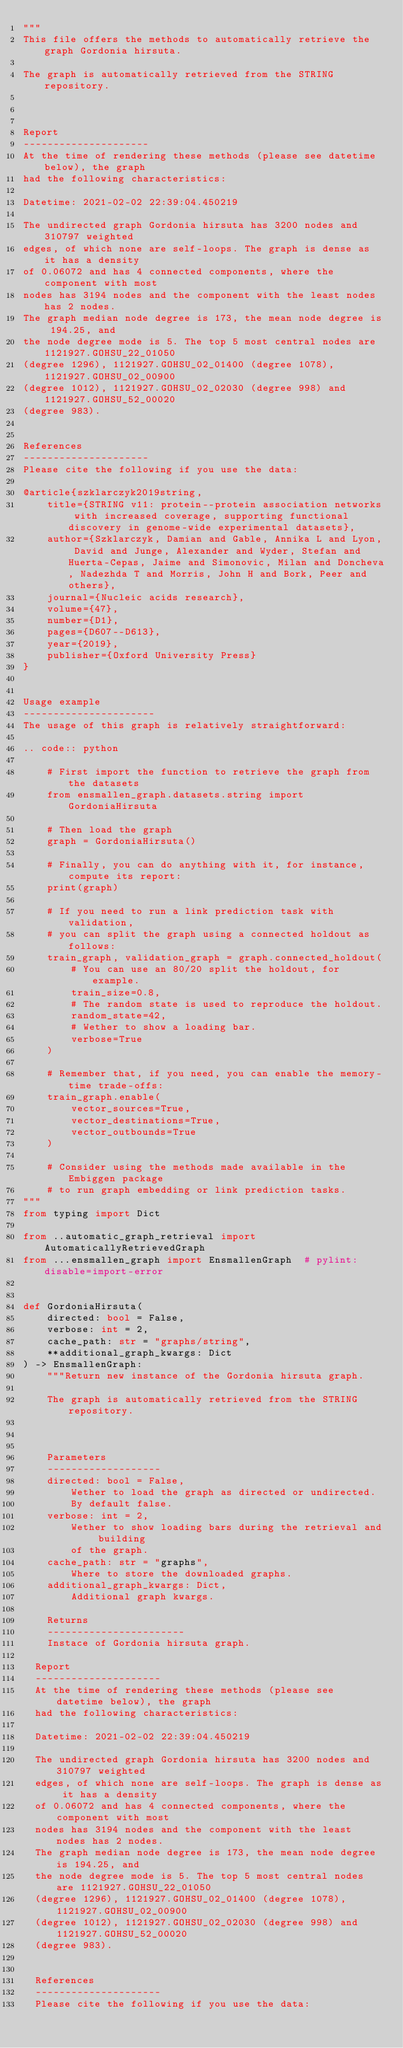<code> <loc_0><loc_0><loc_500><loc_500><_Python_>"""
This file offers the methods to automatically retrieve the graph Gordonia hirsuta.

The graph is automatically retrieved from the STRING repository. 



Report
---------------------
At the time of rendering these methods (please see datetime below), the graph
had the following characteristics:

Datetime: 2021-02-02 22:39:04.450219

The undirected graph Gordonia hirsuta has 3200 nodes and 310797 weighted
edges, of which none are self-loops. The graph is dense as it has a density
of 0.06072 and has 4 connected components, where the component with most
nodes has 3194 nodes and the component with the least nodes has 2 nodes.
The graph median node degree is 173, the mean node degree is 194.25, and
the node degree mode is 5. The top 5 most central nodes are 1121927.GOHSU_22_01050
(degree 1296), 1121927.GOHSU_02_01400 (degree 1078), 1121927.GOHSU_02_00900
(degree 1012), 1121927.GOHSU_02_02030 (degree 998) and 1121927.GOHSU_52_00020
(degree 983).


References
---------------------
Please cite the following if you use the data:

@article{szklarczyk2019string,
    title={STRING v11: protein--protein association networks with increased coverage, supporting functional discovery in genome-wide experimental datasets},
    author={Szklarczyk, Damian and Gable, Annika L and Lyon, David and Junge, Alexander and Wyder, Stefan and Huerta-Cepas, Jaime and Simonovic, Milan and Doncheva, Nadezhda T and Morris, John H and Bork, Peer and others},
    journal={Nucleic acids research},
    volume={47},
    number={D1},
    pages={D607--D613},
    year={2019},
    publisher={Oxford University Press}
}


Usage example
----------------------
The usage of this graph is relatively straightforward:

.. code:: python

    # First import the function to retrieve the graph from the datasets
    from ensmallen_graph.datasets.string import GordoniaHirsuta

    # Then load the graph
    graph = GordoniaHirsuta()

    # Finally, you can do anything with it, for instance, compute its report:
    print(graph)

    # If you need to run a link prediction task with validation,
    # you can split the graph using a connected holdout as follows:
    train_graph, validation_graph = graph.connected_holdout(
        # You can use an 80/20 split the holdout, for example.
        train_size=0.8,
        # The random state is used to reproduce the holdout.
        random_state=42,
        # Wether to show a loading bar.
        verbose=True
    )

    # Remember that, if you need, you can enable the memory-time trade-offs:
    train_graph.enable(
        vector_sources=True,
        vector_destinations=True,
        vector_outbounds=True
    )

    # Consider using the methods made available in the Embiggen package
    # to run graph embedding or link prediction tasks.
"""
from typing import Dict

from ..automatic_graph_retrieval import AutomaticallyRetrievedGraph
from ...ensmallen_graph import EnsmallenGraph  # pylint: disable=import-error


def GordoniaHirsuta(
    directed: bool = False,
    verbose: int = 2,
    cache_path: str = "graphs/string",
    **additional_graph_kwargs: Dict
) -> EnsmallenGraph:
    """Return new instance of the Gordonia hirsuta graph.

    The graph is automatically retrieved from the STRING repository. 

	

    Parameters
    -------------------
    directed: bool = False,
        Wether to load the graph as directed or undirected.
        By default false.
    verbose: int = 2,
        Wether to show loading bars during the retrieval and building
        of the graph.
    cache_path: str = "graphs",
        Where to store the downloaded graphs.
    additional_graph_kwargs: Dict,
        Additional graph kwargs.

    Returns
    -----------------------
    Instace of Gordonia hirsuta graph.

	Report
	---------------------
	At the time of rendering these methods (please see datetime below), the graph
	had the following characteristics:
	
	Datetime: 2021-02-02 22:39:04.450219
	
	The undirected graph Gordonia hirsuta has 3200 nodes and 310797 weighted
	edges, of which none are self-loops. The graph is dense as it has a density
	of 0.06072 and has 4 connected components, where the component with most
	nodes has 3194 nodes and the component with the least nodes has 2 nodes.
	The graph median node degree is 173, the mean node degree is 194.25, and
	the node degree mode is 5. The top 5 most central nodes are 1121927.GOHSU_22_01050
	(degree 1296), 1121927.GOHSU_02_01400 (degree 1078), 1121927.GOHSU_02_00900
	(degree 1012), 1121927.GOHSU_02_02030 (degree 998) and 1121927.GOHSU_52_00020
	(degree 983).
	

	References
	---------------------
	Please cite the following if you use the data:
	</code> 